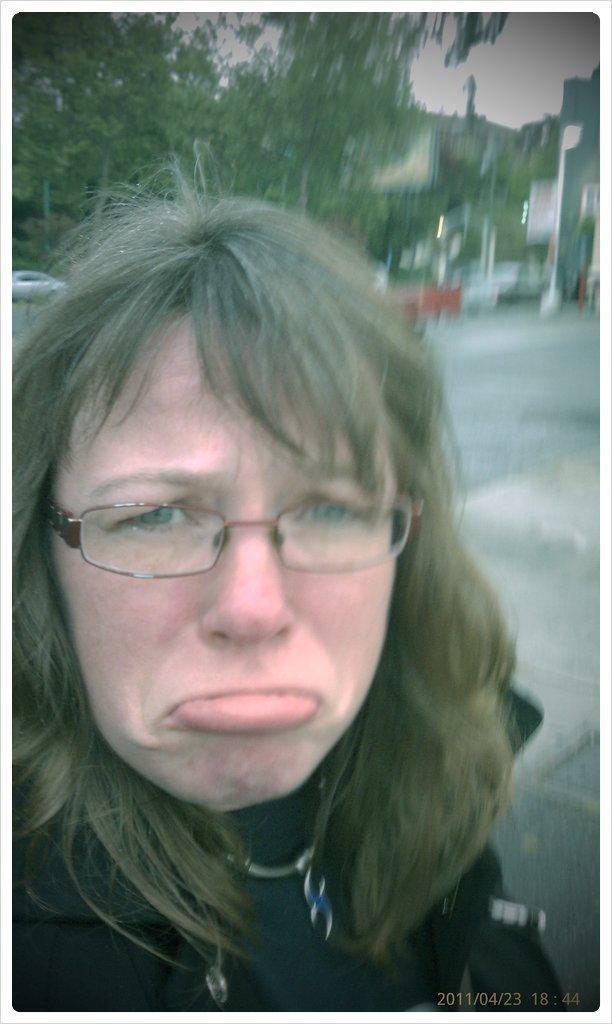How would you summarize this image in a sentence or two? In this image we can see a person with a specs. In the background there are trees. And it is looking blur in the background. Also we can see a car. At the bottom right corner something is written on the image. 